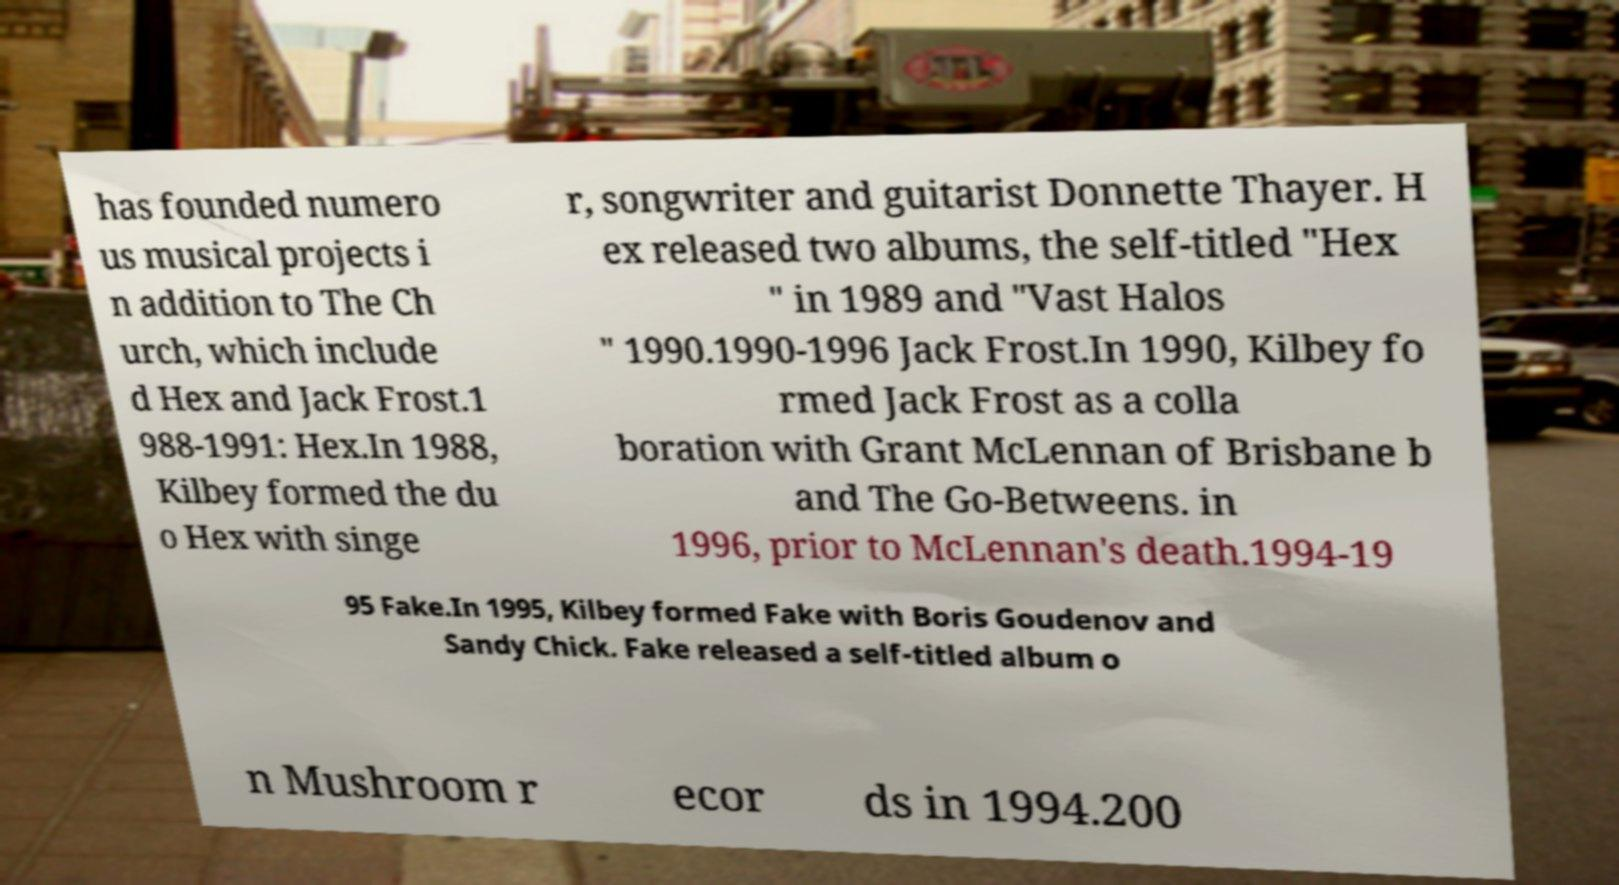What messages or text are displayed in this image? I need them in a readable, typed format. has founded numero us musical projects i n addition to The Ch urch, which include d Hex and Jack Frost.1 988-1991: Hex.In 1988, Kilbey formed the du o Hex with singe r, songwriter and guitarist Donnette Thayer. H ex released two albums, the self-titled "Hex " in 1989 and "Vast Halos " 1990.1990-1996 Jack Frost.In 1990, Kilbey fo rmed Jack Frost as a colla boration with Grant McLennan of Brisbane b and The Go-Betweens. in 1996, prior to McLennan's death.1994-19 95 Fake.In 1995, Kilbey formed Fake with Boris Goudenov and Sandy Chick. Fake released a self-titled album o n Mushroom r ecor ds in 1994.200 